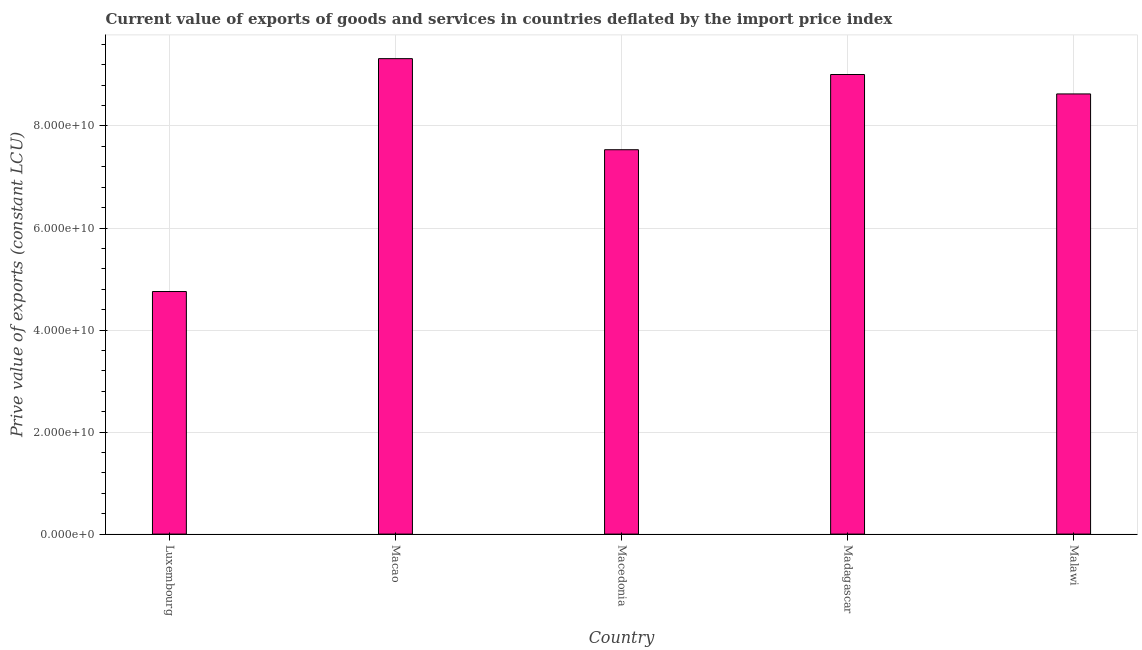Does the graph contain any zero values?
Offer a very short reply. No. What is the title of the graph?
Provide a short and direct response. Current value of exports of goods and services in countries deflated by the import price index. What is the label or title of the X-axis?
Your response must be concise. Country. What is the label or title of the Y-axis?
Offer a terse response. Prive value of exports (constant LCU). What is the price value of exports in Macao?
Provide a short and direct response. 9.32e+1. Across all countries, what is the maximum price value of exports?
Ensure brevity in your answer.  9.32e+1. Across all countries, what is the minimum price value of exports?
Offer a terse response. 4.75e+1. In which country was the price value of exports maximum?
Ensure brevity in your answer.  Macao. In which country was the price value of exports minimum?
Offer a terse response. Luxembourg. What is the sum of the price value of exports?
Provide a succinct answer. 3.92e+11. What is the difference between the price value of exports in Luxembourg and Malawi?
Ensure brevity in your answer.  -3.87e+1. What is the average price value of exports per country?
Give a very brief answer. 7.85e+1. What is the median price value of exports?
Your response must be concise. 8.63e+1. In how many countries, is the price value of exports greater than 64000000000 LCU?
Your answer should be very brief. 4. What is the ratio of the price value of exports in Macao to that in Madagascar?
Keep it short and to the point. 1.03. Is the price value of exports in Macedonia less than that in Madagascar?
Provide a succinct answer. Yes. Is the difference between the price value of exports in Luxembourg and Madagascar greater than the difference between any two countries?
Give a very brief answer. No. What is the difference between the highest and the second highest price value of exports?
Your response must be concise. 3.11e+09. Is the sum of the price value of exports in Macedonia and Malawi greater than the maximum price value of exports across all countries?
Give a very brief answer. Yes. What is the difference between the highest and the lowest price value of exports?
Offer a very short reply. 4.56e+1. In how many countries, is the price value of exports greater than the average price value of exports taken over all countries?
Your answer should be very brief. 3. How many bars are there?
Ensure brevity in your answer.  5. Are all the bars in the graph horizontal?
Make the answer very short. No. What is the Prive value of exports (constant LCU) in Luxembourg?
Ensure brevity in your answer.  4.75e+1. What is the Prive value of exports (constant LCU) of Macao?
Make the answer very short. 9.32e+1. What is the Prive value of exports (constant LCU) of Macedonia?
Give a very brief answer. 7.53e+1. What is the Prive value of exports (constant LCU) in Madagascar?
Ensure brevity in your answer.  9.01e+1. What is the Prive value of exports (constant LCU) in Malawi?
Give a very brief answer. 8.63e+1. What is the difference between the Prive value of exports (constant LCU) in Luxembourg and Macao?
Your response must be concise. -4.56e+1. What is the difference between the Prive value of exports (constant LCU) in Luxembourg and Macedonia?
Keep it short and to the point. -2.78e+1. What is the difference between the Prive value of exports (constant LCU) in Luxembourg and Madagascar?
Provide a succinct answer. -4.25e+1. What is the difference between the Prive value of exports (constant LCU) in Luxembourg and Malawi?
Offer a very short reply. -3.87e+1. What is the difference between the Prive value of exports (constant LCU) in Macao and Macedonia?
Keep it short and to the point. 1.79e+1. What is the difference between the Prive value of exports (constant LCU) in Macao and Madagascar?
Provide a short and direct response. 3.11e+09. What is the difference between the Prive value of exports (constant LCU) in Macao and Malawi?
Offer a very short reply. 6.92e+09. What is the difference between the Prive value of exports (constant LCU) in Macedonia and Madagascar?
Keep it short and to the point. -1.47e+1. What is the difference between the Prive value of exports (constant LCU) in Macedonia and Malawi?
Make the answer very short. -1.09e+1. What is the difference between the Prive value of exports (constant LCU) in Madagascar and Malawi?
Your answer should be compact. 3.81e+09. What is the ratio of the Prive value of exports (constant LCU) in Luxembourg to that in Macao?
Give a very brief answer. 0.51. What is the ratio of the Prive value of exports (constant LCU) in Luxembourg to that in Macedonia?
Make the answer very short. 0.63. What is the ratio of the Prive value of exports (constant LCU) in Luxembourg to that in Madagascar?
Offer a very short reply. 0.53. What is the ratio of the Prive value of exports (constant LCU) in Luxembourg to that in Malawi?
Keep it short and to the point. 0.55. What is the ratio of the Prive value of exports (constant LCU) in Macao to that in Macedonia?
Your answer should be very brief. 1.24. What is the ratio of the Prive value of exports (constant LCU) in Macao to that in Madagascar?
Your answer should be compact. 1.03. What is the ratio of the Prive value of exports (constant LCU) in Macao to that in Malawi?
Your answer should be very brief. 1.08. What is the ratio of the Prive value of exports (constant LCU) in Macedonia to that in Madagascar?
Your response must be concise. 0.84. What is the ratio of the Prive value of exports (constant LCU) in Macedonia to that in Malawi?
Give a very brief answer. 0.87. What is the ratio of the Prive value of exports (constant LCU) in Madagascar to that in Malawi?
Offer a terse response. 1.04. 